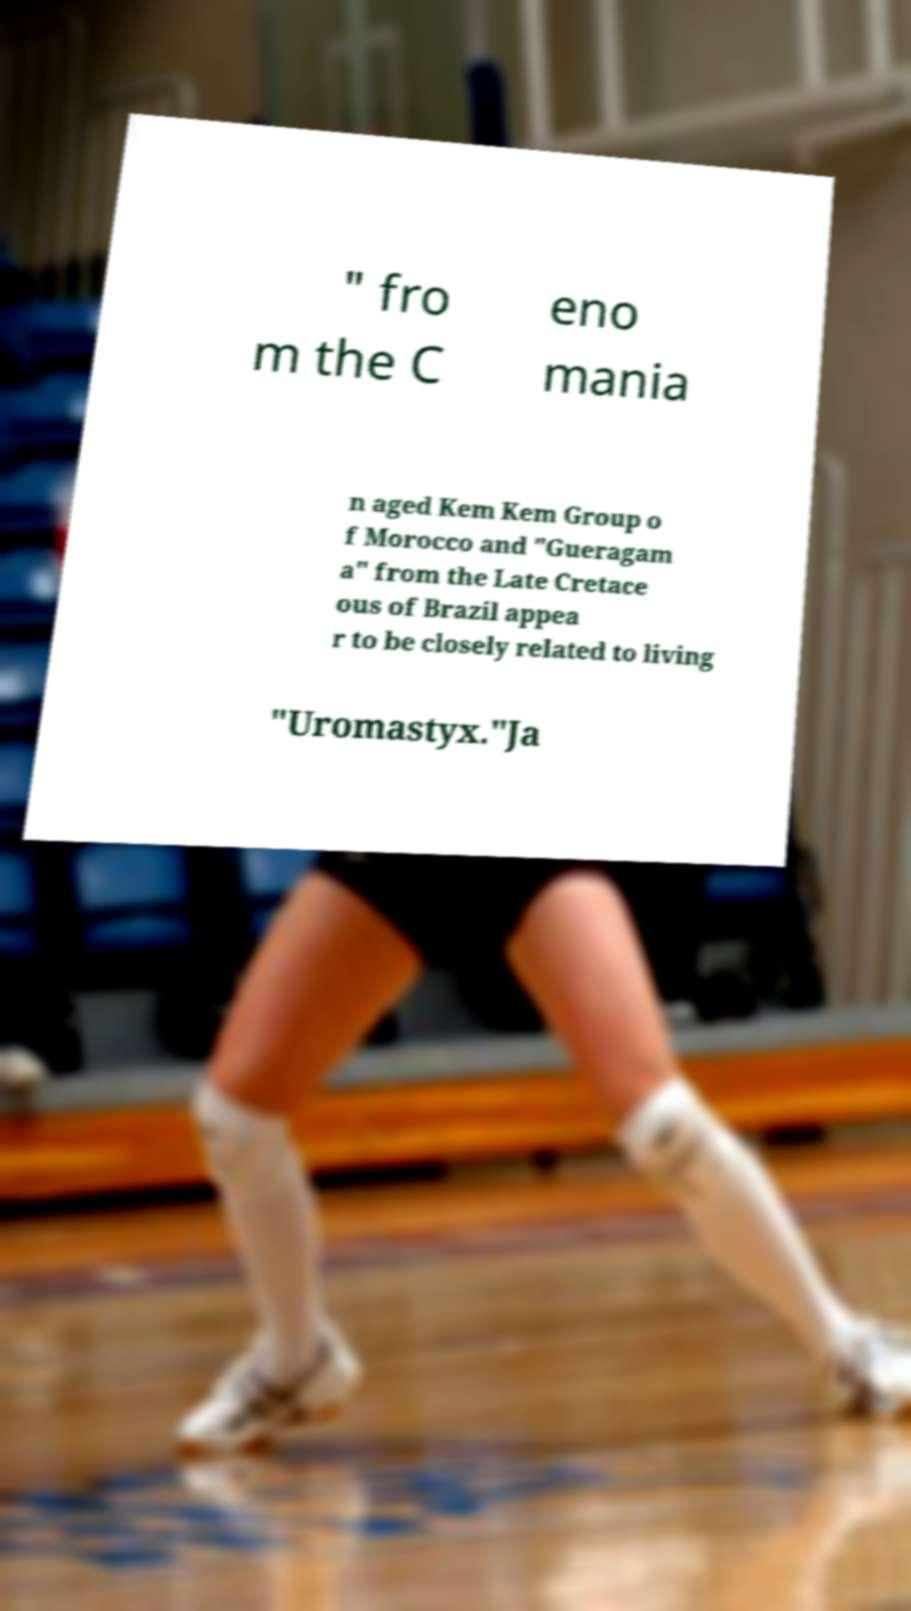I need the written content from this picture converted into text. Can you do that? " fro m the C eno mania n aged Kem Kem Group o f Morocco and "Gueragam a" from the Late Cretace ous of Brazil appea r to be closely related to living "Uromastyx."Ja 